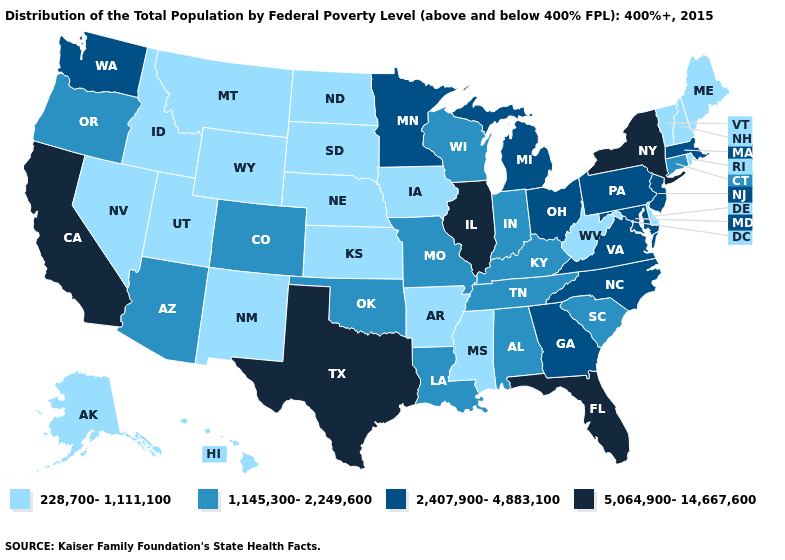Among the states that border Wyoming , which have the highest value?
Quick response, please. Colorado. Does Vermont have the lowest value in the USA?
Short answer required. Yes. What is the lowest value in the MidWest?
Keep it brief. 228,700-1,111,100. What is the value of Ohio?
Short answer required. 2,407,900-4,883,100. Does Minnesota have a higher value than Oregon?
Keep it brief. Yes. Does Colorado have a lower value than Maryland?
Short answer required. Yes. Does Pennsylvania have the highest value in the USA?
Give a very brief answer. No. What is the value of Washington?
Concise answer only. 2,407,900-4,883,100. Name the states that have a value in the range 228,700-1,111,100?
Concise answer only. Alaska, Arkansas, Delaware, Hawaii, Idaho, Iowa, Kansas, Maine, Mississippi, Montana, Nebraska, Nevada, New Hampshire, New Mexico, North Dakota, Rhode Island, South Dakota, Utah, Vermont, West Virginia, Wyoming. What is the highest value in the West ?
Give a very brief answer. 5,064,900-14,667,600. Does the first symbol in the legend represent the smallest category?
Write a very short answer. Yes. Among the states that border Maine , which have the highest value?
Short answer required. New Hampshire. Name the states that have a value in the range 1,145,300-2,249,600?
Write a very short answer. Alabama, Arizona, Colorado, Connecticut, Indiana, Kentucky, Louisiana, Missouri, Oklahoma, Oregon, South Carolina, Tennessee, Wisconsin. Does South Dakota have the highest value in the MidWest?
Concise answer only. No. What is the value of Alaska?
Short answer required. 228,700-1,111,100. 